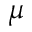Convert formula to latex. <formula><loc_0><loc_0><loc_500><loc_500>\mu</formula> 